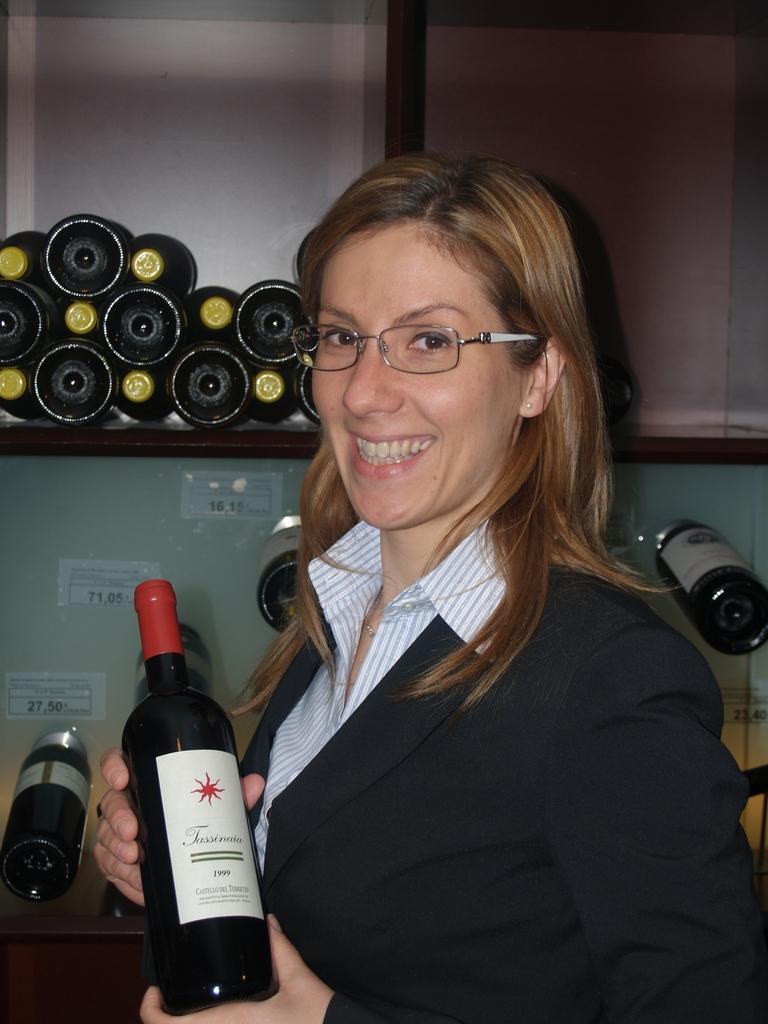Could you give a brief overview of what you see in this image? this picture shows a woman standing with a smile on her face holding a wine bottle in her hands and we see few bottles on her back in the cupboard 